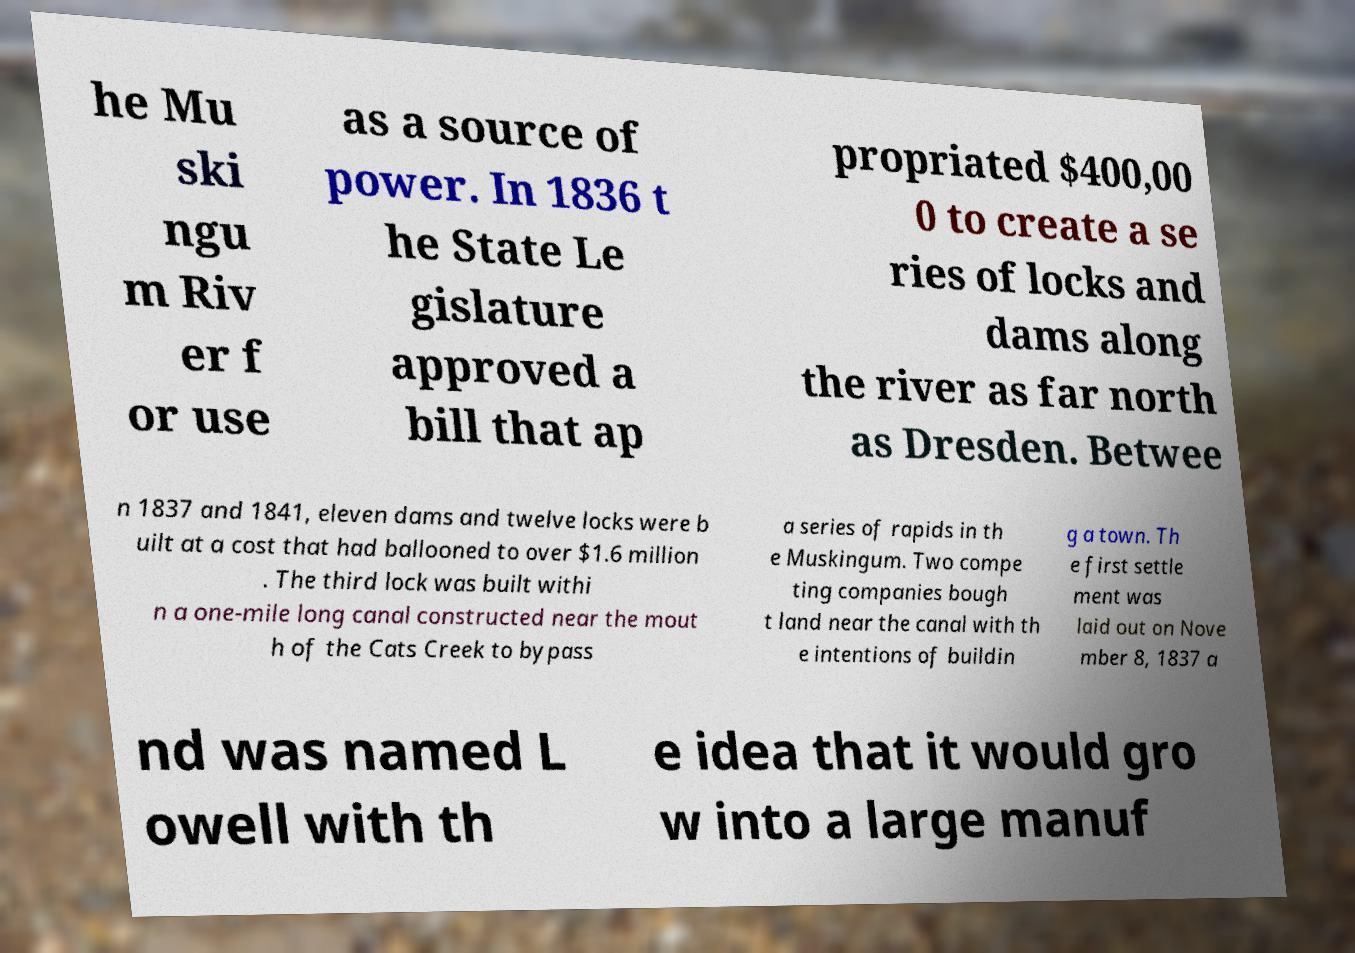Could you assist in decoding the text presented in this image and type it out clearly? he Mu ski ngu m Riv er f or use as a source of power. In 1836 t he State Le gislature approved a bill that ap propriated $400,00 0 to create a se ries of locks and dams along the river as far north as Dresden. Betwee n 1837 and 1841, eleven dams and twelve locks were b uilt at a cost that had ballooned to over $1.6 million . The third lock was built withi n a one-mile long canal constructed near the mout h of the Cats Creek to bypass a series of rapids in th e Muskingum. Two compe ting companies bough t land near the canal with th e intentions of buildin g a town. Th e first settle ment was laid out on Nove mber 8, 1837 a nd was named L owell with th e idea that it would gro w into a large manuf 